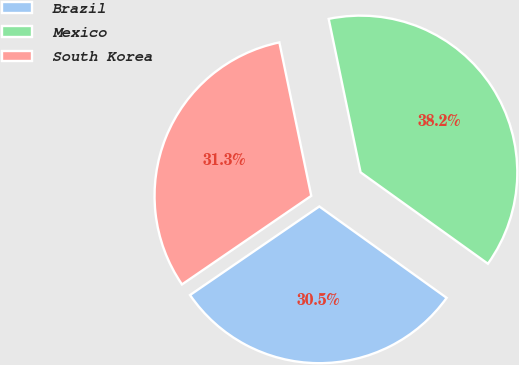Convert chart. <chart><loc_0><loc_0><loc_500><loc_500><pie_chart><fcel>Brazil<fcel>Mexico<fcel>South Korea<nl><fcel>30.53%<fcel>38.17%<fcel>31.3%<nl></chart> 